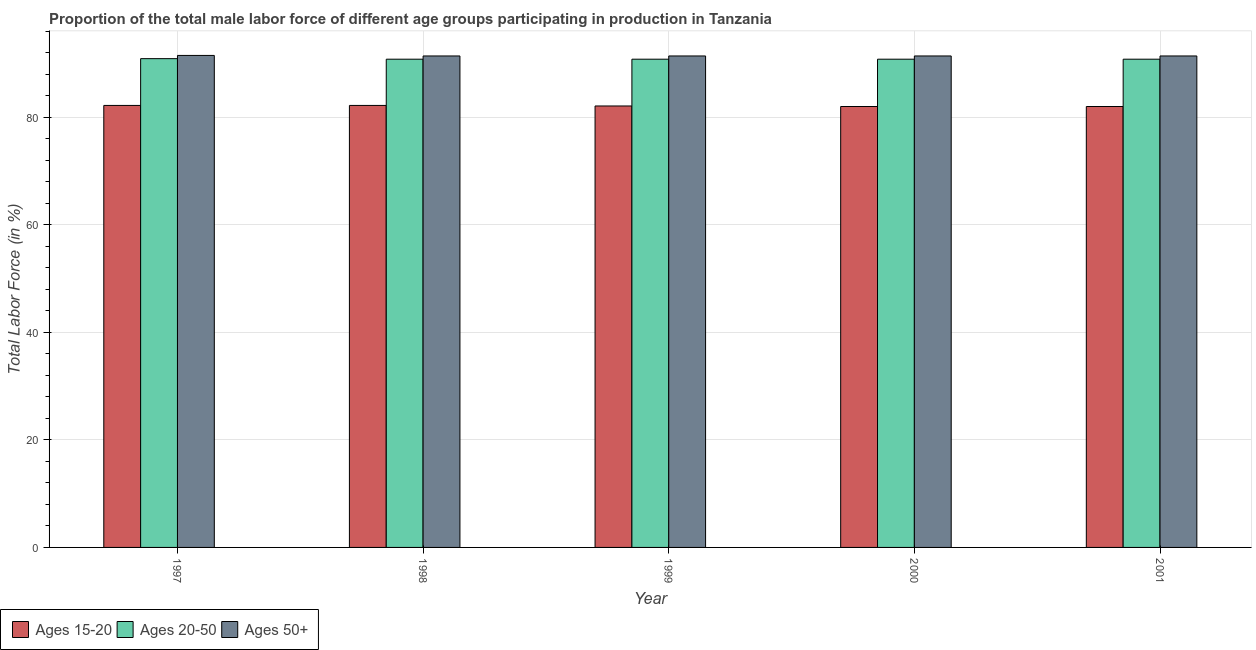How many different coloured bars are there?
Keep it short and to the point. 3. How many bars are there on the 3rd tick from the left?
Provide a short and direct response. 3. How many bars are there on the 1st tick from the right?
Give a very brief answer. 3. What is the label of the 3rd group of bars from the left?
Provide a succinct answer. 1999. In how many cases, is the number of bars for a given year not equal to the number of legend labels?
Give a very brief answer. 0. What is the percentage of male labor force within the age group 20-50 in 1998?
Give a very brief answer. 90.8. Across all years, what is the maximum percentage of male labor force within the age group 15-20?
Provide a succinct answer. 82.2. Across all years, what is the minimum percentage of male labor force within the age group 20-50?
Provide a succinct answer. 90.8. What is the total percentage of male labor force within the age group 20-50 in the graph?
Your answer should be compact. 454.1. What is the difference between the percentage of male labor force within the age group 15-20 in 1999 and the percentage of male labor force within the age group 20-50 in 1998?
Give a very brief answer. -0.1. What is the average percentage of male labor force above age 50 per year?
Offer a very short reply. 91.42. In the year 1998, what is the difference between the percentage of male labor force above age 50 and percentage of male labor force within the age group 15-20?
Your response must be concise. 0. In how many years, is the percentage of male labor force within the age group 20-50 greater than 4 %?
Provide a succinct answer. 5. What is the ratio of the percentage of male labor force within the age group 15-20 in 1997 to that in 2001?
Make the answer very short. 1. What is the difference between the highest and the second highest percentage of male labor force within the age group 20-50?
Give a very brief answer. 0.1. What is the difference between the highest and the lowest percentage of male labor force within the age group 15-20?
Your answer should be compact. 0.2. In how many years, is the percentage of male labor force within the age group 15-20 greater than the average percentage of male labor force within the age group 15-20 taken over all years?
Give a very brief answer. 2. Is the sum of the percentage of male labor force within the age group 15-20 in 1997 and 1999 greater than the maximum percentage of male labor force above age 50 across all years?
Provide a succinct answer. Yes. What does the 2nd bar from the left in 1997 represents?
Your answer should be compact. Ages 20-50. What does the 1st bar from the right in 2001 represents?
Provide a short and direct response. Ages 50+. How many bars are there?
Give a very brief answer. 15. How many years are there in the graph?
Give a very brief answer. 5. Does the graph contain any zero values?
Your answer should be compact. No. Where does the legend appear in the graph?
Your answer should be compact. Bottom left. How many legend labels are there?
Make the answer very short. 3. How are the legend labels stacked?
Your answer should be very brief. Horizontal. What is the title of the graph?
Make the answer very short. Proportion of the total male labor force of different age groups participating in production in Tanzania. What is the Total Labor Force (in %) in Ages 15-20 in 1997?
Keep it short and to the point. 82.2. What is the Total Labor Force (in %) in Ages 20-50 in 1997?
Keep it short and to the point. 90.9. What is the Total Labor Force (in %) in Ages 50+ in 1997?
Your answer should be very brief. 91.5. What is the Total Labor Force (in %) of Ages 15-20 in 1998?
Provide a short and direct response. 82.2. What is the Total Labor Force (in %) in Ages 20-50 in 1998?
Provide a short and direct response. 90.8. What is the Total Labor Force (in %) in Ages 50+ in 1998?
Offer a terse response. 91.4. What is the Total Labor Force (in %) of Ages 15-20 in 1999?
Keep it short and to the point. 82.1. What is the Total Labor Force (in %) in Ages 20-50 in 1999?
Your answer should be very brief. 90.8. What is the Total Labor Force (in %) of Ages 50+ in 1999?
Give a very brief answer. 91.4. What is the Total Labor Force (in %) in Ages 15-20 in 2000?
Offer a terse response. 82. What is the Total Labor Force (in %) of Ages 20-50 in 2000?
Provide a short and direct response. 90.8. What is the Total Labor Force (in %) of Ages 50+ in 2000?
Provide a short and direct response. 91.4. What is the Total Labor Force (in %) of Ages 20-50 in 2001?
Offer a very short reply. 90.8. What is the Total Labor Force (in %) of Ages 50+ in 2001?
Your answer should be compact. 91.4. Across all years, what is the maximum Total Labor Force (in %) in Ages 15-20?
Give a very brief answer. 82.2. Across all years, what is the maximum Total Labor Force (in %) in Ages 20-50?
Offer a very short reply. 90.9. Across all years, what is the maximum Total Labor Force (in %) in Ages 50+?
Ensure brevity in your answer.  91.5. Across all years, what is the minimum Total Labor Force (in %) of Ages 20-50?
Offer a terse response. 90.8. Across all years, what is the minimum Total Labor Force (in %) of Ages 50+?
Ensure brevity in your answer.  91.4. What is the total Total Labor Force (in %) of Ages 15-20 in the graph?
Make the answer very short. 410.5. What is the total Total Labor Force (in %) of Ages 20-50 in the graph?
Offer a terse response. 454.1. What is the total Total Labor Force (in %) of Ages 50+ in the graph?
Your response must be concise. 457.1. What is the difference between the Total Labor Force (in %) in Ages 15-20 in 1997 and that in 1998?
Your response must be concise. 0. What is the difference between the Total Labor Force (in %) in Ages 50+ in 1997 and that in 1999?
Your answer should be compact. 0.1. What is the difference between the Total Labor Force (in %) in Ages 15-20 in 1997 and that in 2000?
Make the answer very short. 0.2. What is the difference between the Total Labor Force (in %) in Ages 20-50 in 1997 and that in 2001?
Provide a short and direct response. 0.1. What is the difference between the Total Labor Force (in %) in Ages 20-50 in 1998 and that in 1999?
Provide a succinct answer. 0. What is the difference between the Total Labor Force (in %) of Ages 50+ in 1998 and that in 1999?
Provide a succinct answer. 0. What is the difference between the Total Labor Force (in %) of Ages 15-20 in 1998 and that in 2000?
Provide a succinct answer. 0.2. What is the difference between the Total Labor Force (in %) in Ages 20-50 in 1998 and that in 2000?
Make the answer very short. 0. What is the difference between the Total Labor Force (in %) of Ages 50+ in 1998 and that in 2000?
Ensure brevity in your answer.  0. What is the difference between the Total Labor Force (in %) of Ages 15-20 in 1998 and that in 2001?
Keep it short and to the point. 0.2. What is the difference between the Total Labor Force (in %) of Ages 15-20 in 1999 and that in 2000?
Make the answer very short. 0.1. What is the difference between the Total Labor Force (in %) in Ages 50+ in 1999 and that in 2000?
Give a very brief answer. 0. What is the difference between the Total Labor Force (in %) in Ages 15-20 in 2000 and that in 2001?
Keep it short and to the point. 0. What is the difference between the Total Labor Force (in %) in Ages 20-50 in 2000 and that in 2001?
Provide a succinct answer. 0. What is the difference between the Total Labor Force (in %) of Ages 15-20 in 1997 and the Total Labor Force (in %) of Ages 20-50 in 1998?
Make the answer very short. -8.6. What is the difference between the Total Labor Force (in %) of Ages 15-20 in 1997 and the Total Labor Force (in %) of Ages 50+ in 1998?
Provide a short and direct response. -9.2. What is the difference between the Total Labor Force (in %) of Ages 20-50 in 1997 and the Total Labor Force (in %) of Ages 50+ in 1998?
Your answer should be very brief. -0.5. What is the difference between the Total Labor Force (in %) in Ages 15-20 in 1997 and the Total Labor Force (in %) in Ages 20-50 in 1999?
Ensure brevity in your answer.  -8.6. What is the difference between the Total Labor Force (in %) in Ages 15-20 in 1997 and the Total Labor Force (in %) in Ages 20-50 in 2000?
Provide a succinct answer. -8.6. What is the difference between the Total Labor Force (in %) of Ages 20-50 in 1997 and the Total Labor Force (in %) of Ages 50+ in 2000?
Keep it short and to the point. -0.5. What is the difference between the Total Labor Force (in %) of Ages 15-20 in 1997 and the Total Labor Force (in %) of Ages 50+ in 2001?
Your response must be concise. -9.2. What is the difference between the Total Labor Force (in %) of Ages 20-50 in 1997 and the Total Labor Force (in %) of Ages 50+ in 2001?
Offer a terse response. -0.5. What is the difference between the Total Labor Force (in %) in Ages 15-20 in 1998 and the Total Labor Force (in %) in Ages 20-50 in 2000?
Your answer should be very brief. -8.6. What is the difference between the Total Labor Force (in %) in Ages 20-50 in 1998 and the Total Labor Force (in %) in Ages 50+ in 2001?
Provide a succinct answer. -0.6. What is the difference between the Total Labor Force (in %) of Ages 15-20 in 1999 and the Total Labor Force (in %) of Ages 20-50 in 2000?
Ensure brevity in your answer.  -8.7. What is the difference between the Total Labor Force (in %) of Ages 15-20 in 1999 and the Total Labor Force (in %) of Ages 50+ in 2000?
Ensure brevity in your answer.  -9.3. What is the difference between the Total Labor Force (in %) of Ages 15-20 in 1999 and the Total Labor Force (in %) of Ages 20-50 in 2001?
Your answer should be compact. -8.7. What is the difference between the Total Labor Force (in %) of Ages 15-20 in 1999 and the Total Labor Force (in %) of Ages 50+ in 2001?
Provide a short and direct response. -9.3. What is the difference between the Total Labor Force (in %) of Ages 15-20 in 2000 and the Total Labor Force (in %) of Ages 20-50 in 2001?
Offer a terse response. -8.8. What is the difference between the Total Labor Force (in %) in Ages 20-50 in 2000 and the Total Labor Force (in %) in Ages 50+ in 2001?
Keep it short and to the point. -0.6. What is the average Total Labor Force (in %) of Ages 15-20 per year?
Offer a very short reply. 82.1. What is the average Total Labor Force (in %) of Ages 20-50 per year?
Your answer should be compact. 90.82. What is the average Total Labor Force (in %) of Ages 50+ per year?
Your answer should be compact. 91.42. In the year 1997, what is the difference between the Total Labor Force (in %) in Ages 15-20 and Total Labor Force (in %) in Ages 20-50?
Your response must be concise. -8.7. In the year 1997, what is the difference between the Total Labor Force (in %) of Ages 15-20 and Total Labor Force (in %) of Ages 50+?
Offer a very short reply. -9.3. In the year 1998, what is the difference between the Total Labor Force (in %) of Ages 15-20 and Total Labor Force (in %) of Ages 20-50?
Your response must be concise. -8.6. In the year 1999, what is the difference between the Total Labor Force (in %) of Ages 15-20 and Total Labor Force (in %) of Ages 20-50?
Make the answer very short. -8.7. In the year 1999, what is the difference between the Total Labor Force (in %) in Ages 15-20 and Total Labor Force (in %) in Ages 50+?
Your answer should be very brief. -9.3. In the year 1999, what is the difference between the Total Labor Force (in %) of Ages 20-50 and Total Labor Force (in %) of Ages 50+?
Offer a terse response. -0.6. In the year 2000, what is the difference between the Total Labor Force (in %) of Ages 15-20 and Total Labor Force (in %) of Ages 50+?
Provide a succinct answer. -9.4. In the year 2000, what is the difference between the Total Labor Force (in %) of Ages 20-50 and Total Labor Force (in %) of Ages 50+?
Keep it short and to the point. -0.6. In the year 2001, what is the difference between the Total Labor Force (in %) in Ages 15-20 and Total Labor Force (in %) in Ages 20-50?
Make the answer very short. -8.8. In the year 2001, what is the difference between the Total Labor Force (in %) in Ages 15-20 and Total Labor Force (in %) in Ages 50+?
Offer a terse response. -9.4. What is the ratio of the Total Labor Force (in %) in Ages 15-20 in 1997 to that in 1998?
Provide a short and direct response. 1. What is the ratio of the Total Labor Force (in %) of Ages 50+ in 1997 to that in 1998?
Offer a very short reply. 1. What is the ratio of the Total Labor Force (in %) of Ages 20-50 in 1997 to that in 1999?
Provide a short and direct response. 1. What is the ratio of the Total Labor Force (in %) in Ages 15-20 in 1997 to that in 2000?
Your answer should be compact. 1. What is the ratio of the Total Labor Force (in %) in Ages 20-50 in 1997 to that in 2000?
Your answer should be compact. 1. What is the ratio of the Total Labor Force (in %) of Ages 50+ in 1997 to that in 2000?
Provide a short and direct response. 1. What is the ratio of the Total Labor Force (in %) in Ages 15-20 in 1997 to that in 2001?
Offer a terse response. 1. What is the ratio of the Total Labor Force (in %) of Ages 20-50 in 1997 to that in 2001?
Your response must be concise. 1. What is the ratio of the Total Labor Force (in %) in Ages 15-20 in 1998 to that in 2000?
Offer a very short reply. 1. What is the ratio of the Total Labor Force (in %) of Ages 20-50 in 1998 to that in 2000?
Offer a very short reply. 1. What is the ratio of the Total Labor Force (in %) of Ages 20-50 in 1998 to that in 2001?
Give a very brief answer. 1. What is the ratio of the Total Labor Force (in %) in Ages 50+ in 1998 to that in 2001?
Give a very brief answer. 1. What is the ratio of the Total Labor Force (in %) of Ages 15-20 in 1999 to that in 2000?
Offer a terse response. 1. What is the ratio of the Total Labor Force (in %) of Ages 20-50 in 1999 to that in 2000?
Provide a short and direct response. 1. What is the ratio of the Total Labor Force (in %) in Ages 15-20 in 1999 to that in 2001?
Ensure brevity in your answer.  1. What is the ratio of the Total Labor Force (in %) in Ages 20-50 in 1999 to that in 2001?
Give a very brief answer. 1. What is the ratio of the Total Labor Force (in %) of Ages 50+ in 1999 to that in 2001?
Ensure brevity in your answer.  1. What is the ratio of the Total Labor Force (in %) of Ages 50+ in 2000 to that in 2001?
Offer a terse response. 1. What is the difference between the highest and the second highest Total Labor Force (in %) of Ages 20-50?
Provide a succinct answer. 0.1. What is the difference between the highest and the second highest Total Labor Force (in %) in Ages 50+?
Your answer should be compact. 0.1. What is the difference between the highest and the lowest Total Labor Force (in %) of Ages 15-20?
Make the answer very short. 0.2. What is the difference between the highest and the lowest Total Labor Force (in %) in Ages 50+?
Keep it short and to the point. 0.1. 